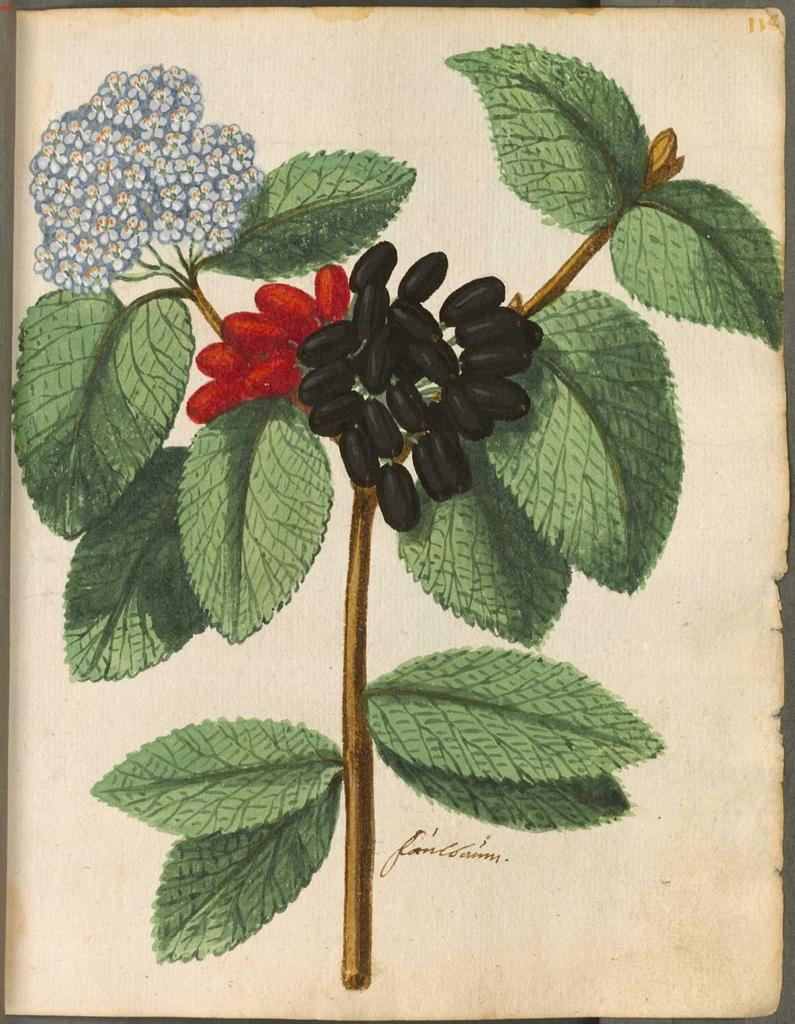What is depicted in the painting in the image? There is a painting of a plant in the image. What features of the plant are visible in the painting? The plant has fruits and flowers in the painting. What else can be seen in the image besides the painting? There is text on a paper in the image. What is the tendency of the jelly in the image? There is no jelly present in the image, so it is not possible to determine its tendency. 